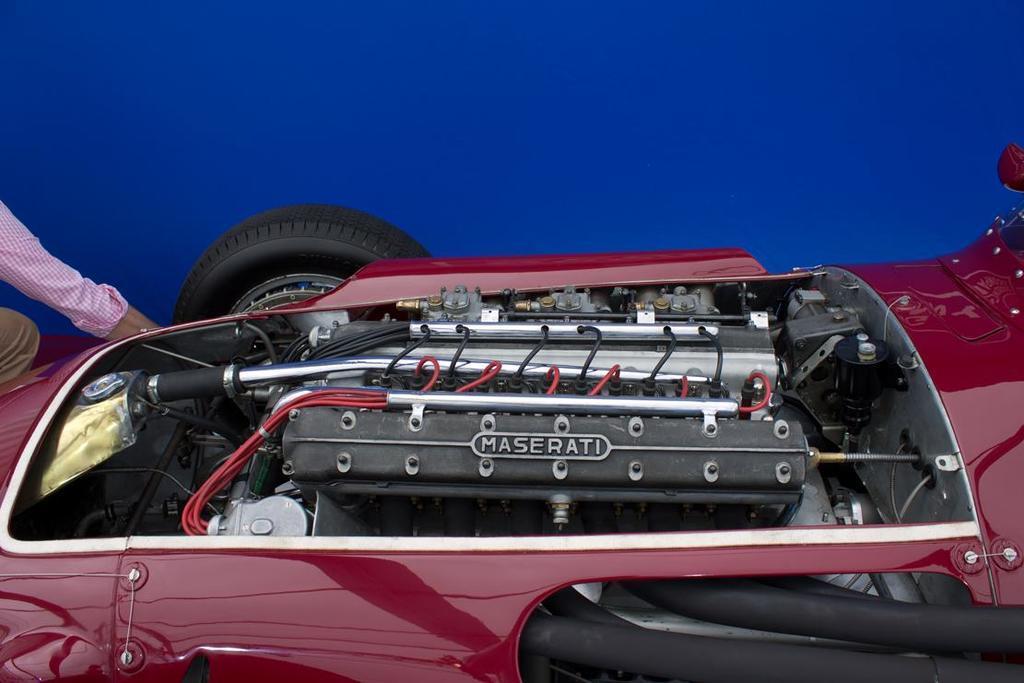Please provide a concise description of this image. Here in this picture we can see an engine of a car and we can also see wheels with tires present and on the left side we can see a person present. 